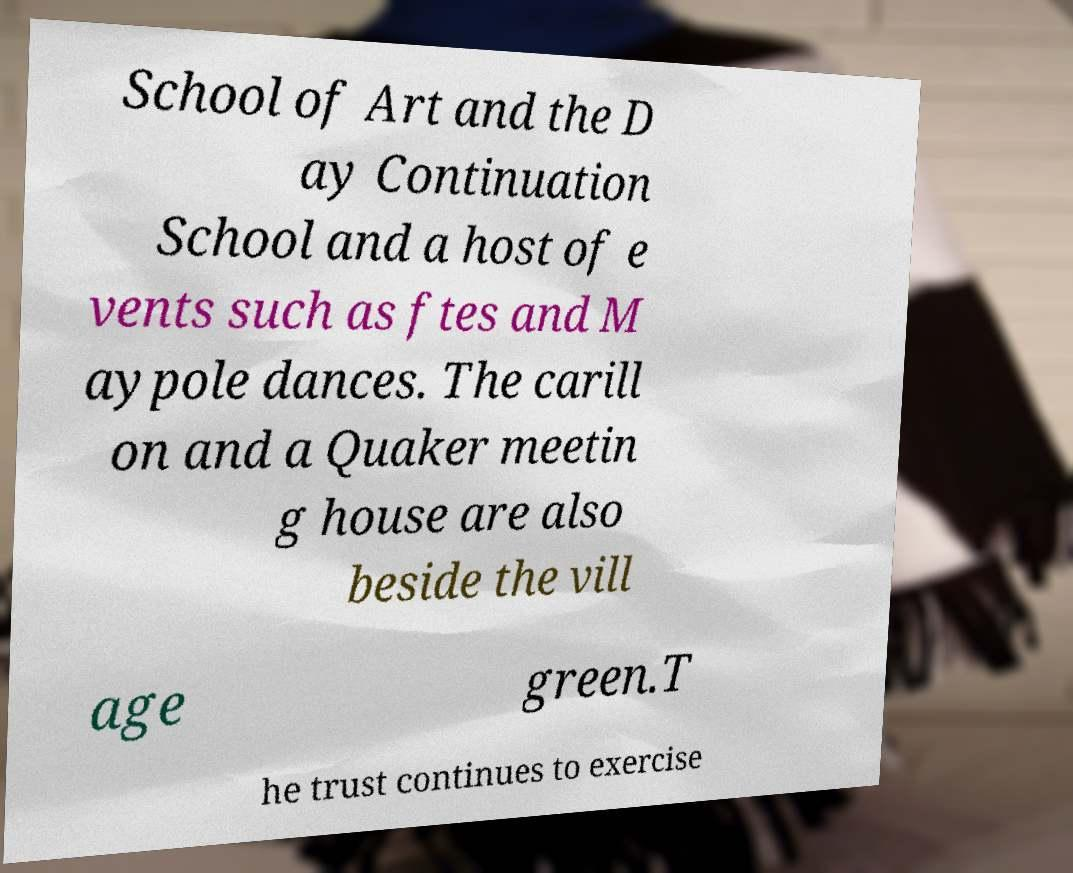Please read and relay the text visible in this image. What does it say? School of Art and the D ay Continuation School and a host of e vents such as ftes and M aypole dances. The carill on and a Quaker meetin g house are also beside the vill age green.T he trust continues to exercise 